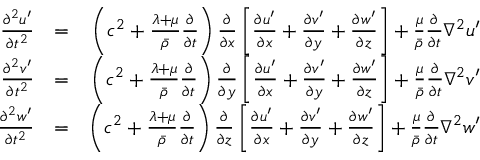Convert formula to latex. <formula><loc_0><loc_0><loc_500><loc_500>\begin{array} { r l r } { \frac { \partial ^ { 2 } u ^ { \prime } } { \partial t ^ { 2 } } } & { = } & { \left ( c ^ { 2 } + \frac { \lambda + \mu } { \bar { \rho } } \frac { \partial } { \partial t } \right ) \frac { \partial } { \partial x } \left [ \frac { \partial u ^ { \prime } } { \partial x } + \frac { \partial v ^ { \prime } } { \partial y } + \frac { \partial w ^ { \prime } } { \partial z } \right ] + \frac { \mu } { \bar { \rho } } \frac { \partial } { \partial t } \nabla ^ { 2 } u ^ { \prime } } \\ { \frac { \partial ^ { 2 } v ^ { \prime } } { \partial t ^ { 2 } } } & { = } & { \left ( c ^ { 2 } + \frac { \lambda + \mu } { \bar { \rho } } \frac { \partial } { \partial t } \right ) \frac { \partial } { \partial y } \left [ \frac { \partial u ^ { \prime } } { \partial x } + \frac { \partial v ^ { \prime } } { \partial y } + \frac { \partial w ^ { \prime } } { \partial z } \right ] + \frac { \mu } { \bar { \rho } } \frac { \partial } { \partial t } \nabla ^ { 2 } v ^ { \prime } } \\ { \frac { \partial ^ { 2 } w ^ { \prime } } { \partial t ^ { 2 } } } & { = } & { \left ( c ^ { 2 } + \frac { \lambda + \mu } { \bar { \rho } } \frac { \partial } { \partial t } \right ) \frac { \partial } { \partial z } \left [ \frac { \partial u ^ { \prime } } { \partial x } + \frac { \partial v ^ { \prime } } { \partial y } + \frac { \partial w ^ { \prime } } { \partial z } \right ] + \frac { \mu } { \bar { \rho } } \frac { \partial } { \partial t } \nabla ^ { 2 } w ^ { \prime } } \end{array}</formula> 